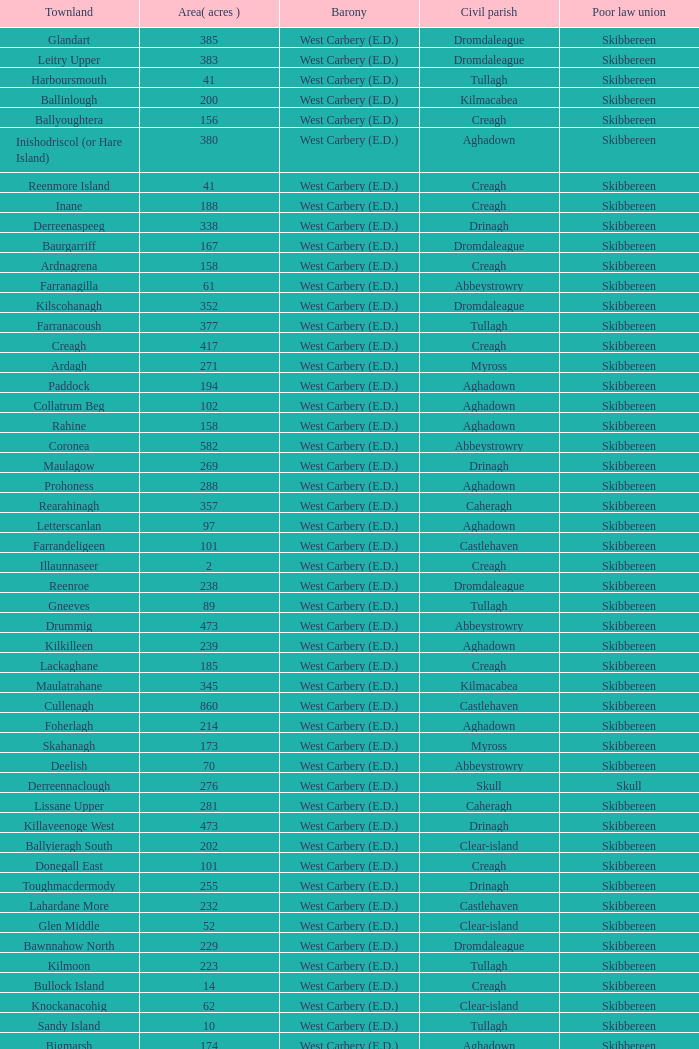What is the greatest area when the Poor Law Union is Skibbereen and the Civil Parish is Tullagh? 796.0. 